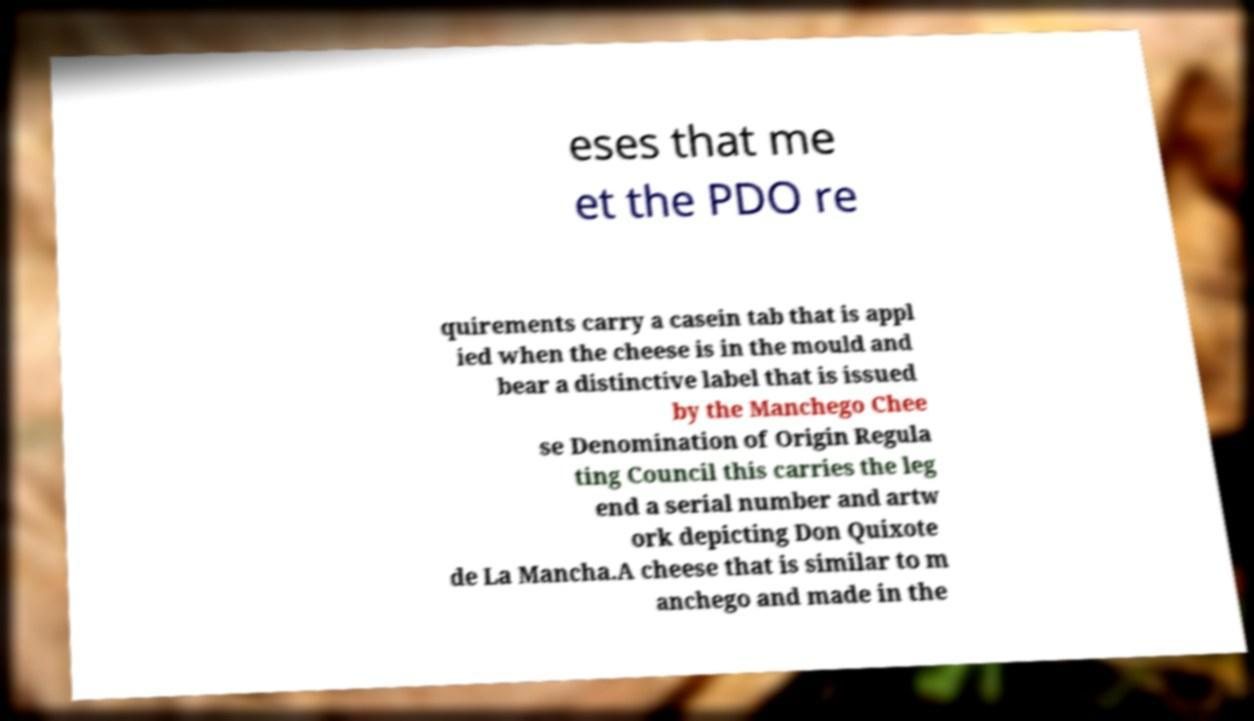There's text embedded in this image that I need extracted. Can you transcribe it verbatim? eses that me et the PDO re quirements carry a casein tab that is appl ied when the cheese is in the mould and bear a distinctive label that is issued by the Manchego Chee se Denomination of Origin Regula ting Council this carries the leg end a serial number and artw ork depicting Don Quixote de La Mancha.A cheese that is similar to m anchego and made in the 